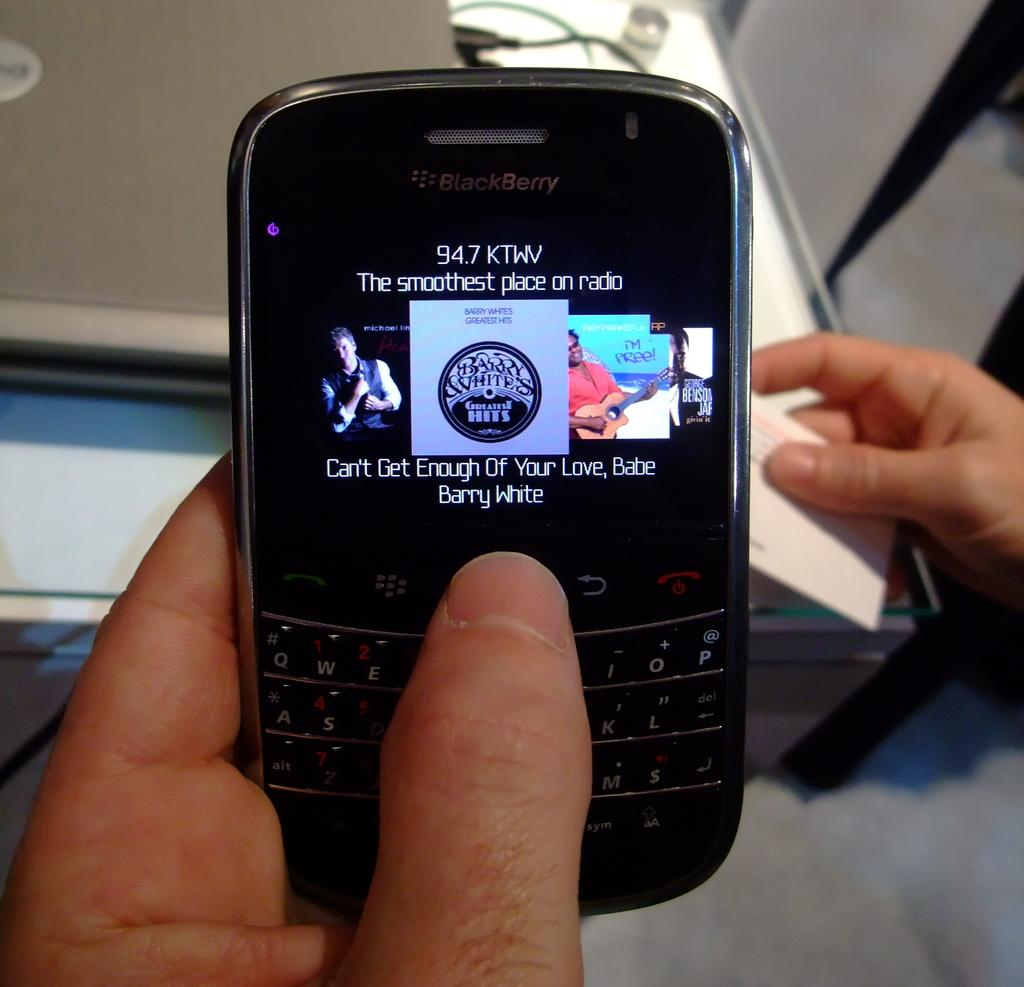<image>
Render a clear and concise summary of the photo. Someone searching through their music list on their blackberry 